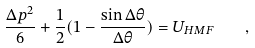Convert formula to latex. <formula><loc_0><loc_0><loc_500><loc_500>\frac { \Delta p ^ { 2 } } { 6 } + \frac { 1 } { 2 } ( 1 - \frac { \sin \Delta \theta } { \Delta \theta } ) = U _ { H M F } \quad ,</formula> 